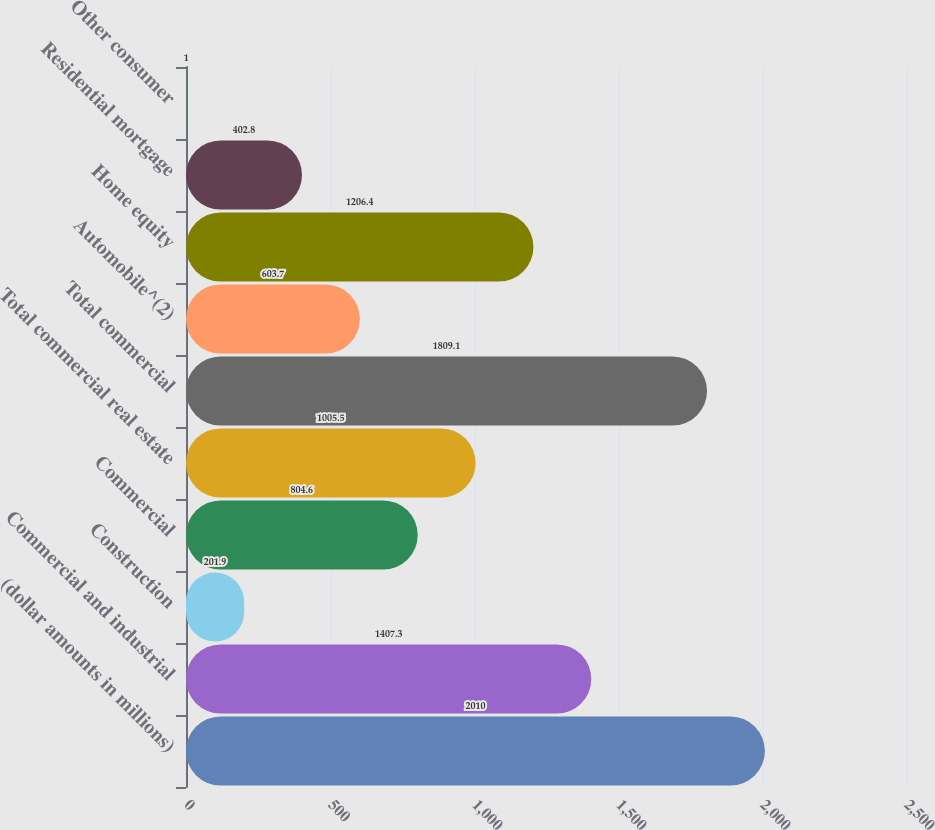<chart> <loc_0><loc_0><loc_500><loc_500><bar_chart><fcel>(dollar amounts in millions)<fcel>Commercial and industrial<fcel>Construction<fcel>Commercial<fcel>Total commercial real estate<fcel>Total commercial<fcel>Automobile^(2)<fcel>Home equity<fcel>Residential mortgage<fcel>Other consumer<nl><fcel>2010<fcel>1407.3<fcel>201.9<fcel>804.6<fcel>1005.5<fcel>1809.1<fcel>603.7<fcel>1206.4<fcel>402.8<fcel>1<nl></chart> 